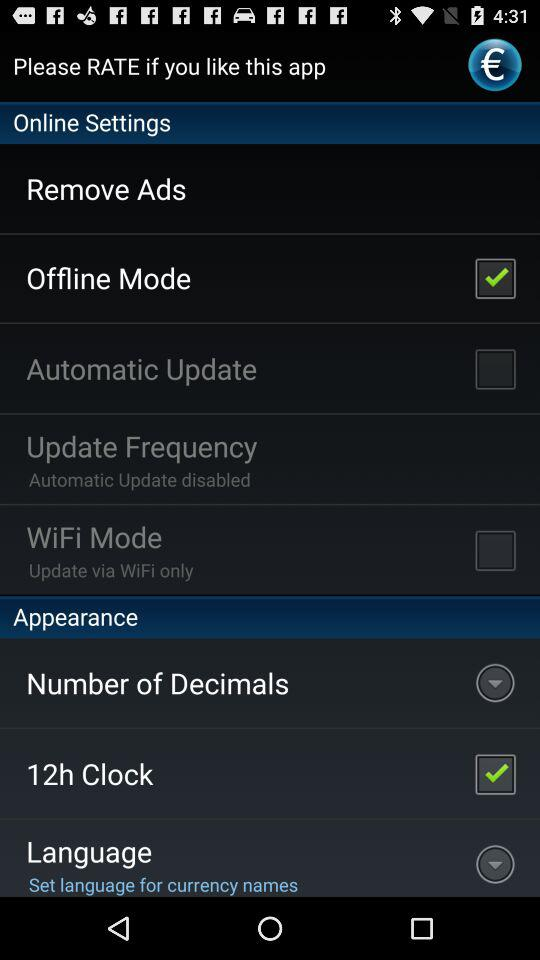What's the checked online setting? The checked online setting is "Offline Mode". 